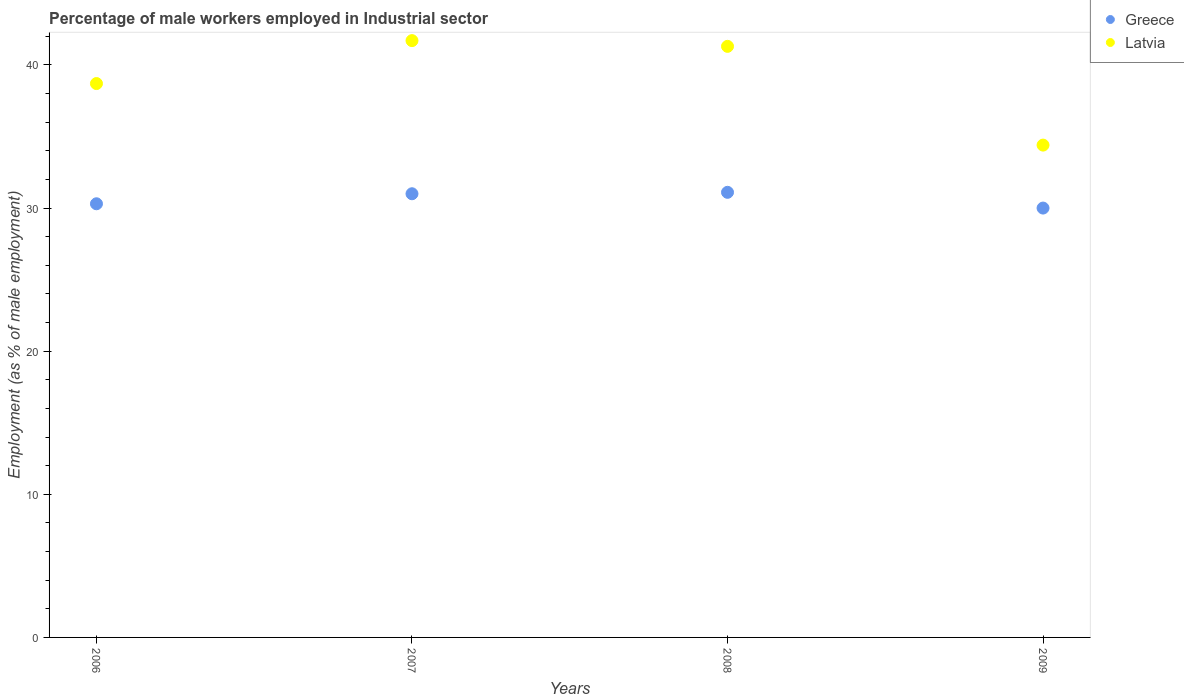What is the percentage of male workers employed in Industrial sector in Latvia in 2007?
Your answer should be very brief. 41.7. Across all years, what is the maximum percentage of male workers employed in Industrial sector in Latvia?
Your answer should be compact. 41.7. In which year was the percentage of male workers employed in Industrial sector in Greece maximum?
Provide a short and direct response. 2008. What is the total percentage of male workers employed in Industrial sector in Greece in the graph?
Provide a short and direct response. 122.4. What is the difference between the percentage of male workers employed in Industrial sector in Latvia in 2006 and that in 2009?
Give a very brief answer. 4.3. What is the difference between the percentage of male workers employed in Industrial sector in Greece in 2006 and the percentage of male workers employed in Industrial sector in Latvia in 2008?
Offer a very short reply. -11. What is the average percentage of male workers employed in Industrial sector in Greece per year?
Make the answer very short. 30.6. In the year 2006, what is the difference between the percentage of male workers employed in Industrial sector in Greece and percentage of male workers employed in Industrial sector in Latvia?
Ensure brevity in your answer.  -8.4. In how many years, is the percentage of male workers employed in Industrial sector in Greece greater than 32 %?
Your response must be concise. 0. What is the ratio of the percentage of male workers employed in Industrial sector in Greece in 2008 to that in 2009?
Give a very brief answer. 1.04. Is the percentage of male workers employed in Industrial sector in Greece in 2006 less than that in 2008?
Provide a short and direct response. Yes. Is the difference between the percentage of male workers employed in Industrial sector in Greece in 2006 and 2007 greater than the difference between the percentage of male workers employed in Industrial sector in Latvia in 2006 and 2007?
Your response must be concise. Yes. What is the difference between the highest and the second highest percentage of male workers employed in Industrial sector in Greece?
Make the answer very short. 0.1. What is the difference between the highest and the lowest percentage of male workers employed in Industrial sector in Greece?
Ensure brevity in your answer.  1.1. Does the percentage of male workers employed in Industrial sector in Latvia monotonically increase over the years?
Offer a terse response. No. Is the percentage of male workers employed in Industrial sector in Latvia strictly greater than the percentage of male workers employed in Industrial sector in Greece over the years?
Offer a very short reply. Yes. Is the percentage of male workers employed in Industrial sector in Greece strictly less than the percentage of male workers employed in Industrial sector in Latvia over the years?
Offer a terse response. Yes. How many dotlines are there?
Give a very brief answer. 2. How many years are there in the graph?
Your response must be concise. 4. Does the graph contain any zero values?
Keep it short and to the point. No. How many legend labels are there?
Give a very brief answer. 2. What is the title of the graph?
Ensure brevity in your answer.  Percentage of male workers employed in Industrial sector. What is the label or title of the X-axis?
Provide a succinct answer. Years. What is the label or title of the Y-axis?
Provide a succinct answer. Employment (as % of male employment). What is the Employment (as % of male employment) of Greece in 2006?
Offer a very short reply. 30.3. What is the Employment (as % of male employment) of Latvia in 2006?
Keep it short and to the point. 38.7. What is the Employment (as % of male employment) in Greece in 2007?
Give a very brief answer. 31. What is the Employment (as % of male employment) of Latvia in 2007?
Your answer should be very brief. 41.7. What is the Employment (as % of male employment) in Greece in 2008?
Keep it short and to the point. 31.1. What is the Employment (as % of male employment) of Latvia in 2008?
Keep it short and to the point. 41.3. What is the Employment (as % of male employment) in Latvia in 2009?
Your answer should be compact. 34.4. Across all years, what is the maximum Employment (as % of male employment) of Greece?
Give a very brief answer. 31.1. Across all years, what is the maximum Employment (as % of male employment) in Latvia?
Your answer should be compact. 41.7. Across all years, what is the minimum Employment (as % of male employment) of Greece?
Ensure brevity in your answer.  30. Across all years, what is the minimum Employment (as % of male employment) in Latvia?
Ensure brevity in your answer.  34.4. What is the total Employment (as % of male employment) of Greece in the graph?
Provide a short and direct response. 122.4. What is the total Employment (as % of male employment) of Latvia in the graph?
Provide a short and direct response. 156.1. What is the difference between the Employment (as % of male employment) of Greece in 2006 and that in 2009?
Your answer should be very brief. 0.3. What is the difference between the Employment (as % of male employment) in Greece in 2007 and that in 2008?
Your response must be concise. -0.1. What is the difference between the Employment (as % of male employment) of Greece in 2007 and that in 2009?
Provide a succinct answer. 1. What is the difference between the Employment (as % of male employment) in Latvia in 2007 and that in 2009?
Offer a terse response. 7.3. What is the difference between the Employment (as % of male employment) in Greece in 2007 and the Employment (as % of male employment) in Latvia in 2008?
Your answer should be compact. -10.3. What is the difference between the Employment (as % of male employment) of Greece in 2008 and the Employment (as % of male employment) of Latvia in 2009?
Provide a succinct answer. -3.3. What is the average Employment (as % of male employment) of Greece per year?
Keep it short and to the point. 30.6. What is the average Employment (as % of male employment) of Latvia per year?
Provide a short and direct response. 39.02. In the year 2006, what is the difference between the Employment (as % of male employment) in Greece and Employment (as % of male employment) in Latvia?
Your answer should be very brief. -8.4. In the year 2008, what is the difference between the Employment (as % of male employment) of Greece and Employment (as % of male employment) of Latvia?
Give a very brief answer. -10.2. In the year 2009, what is the difference between the Employment (as % of male employment) of Greece and Employment (as % of male employment) of Latvia?
Give a very brief answer. -4.4. What is the ratio of the Employment (as % of male employment) in Greece in 2006 to that in 2007?
Make the answer very short. 0.98. What is the ratio of the Employment (as % of male employment) of Latvia in 2006 to that in 2007?
Make the answer very short. 0.93. What is the ratio of the Employment (as % of male employment) in Greece in 2006 to that in 2008?
Your response must be concise. 0.97. What is the ratio of the Employment (as % of male employment) in Latvia in 2006 to that in 2008?
Ensure brevity in your answer.  0.94. What is the ratio of the Employment (as % of male employment) in Greece in 2006 to that in 2009?
Provide a short and direct response. 1.01. What is the ratio of the Employment (as % of male employment) in Latvia in 2006 to that in 2009?
Ensure brevity in your answer.  1.12. What is the ratio of the Employment (as % of male employment) in Greece in 2007 to that in 2008?
Offer a terse response. 1. What is the ratio of the Employment (as % of male employment) in Latvia in 2007 to that in 2008?
Provide a succinct answer. 1.01. What is the ratio of the Employment (as % of male employment) of Greece in 2007 to that in 2009?
Ensure brevity in your answer.  1.03. What is the ratio of the Employment (as % of male employment) in Latvia in 2007 to that in 2009?
Your answer should be very brief. 1.21. What is the ratio of the Employment (as % of male employment) in Greece in 2008 to that in 2009?
Your answer should be compact. 1.04. What is the ratio of the Employment (as % of male employment) of Latvia in 2008 to that in 2009?
Provide a short and direct response. 1.2. What is the difference between the highest and the second highest Employment (as % of male employment) in Latvia?
Provide a succinct answer. 0.4. What is the difference between the highest and the lowest Employment (as % of male employment) in Latvia?
Keep it short and to the point. 7.3. 